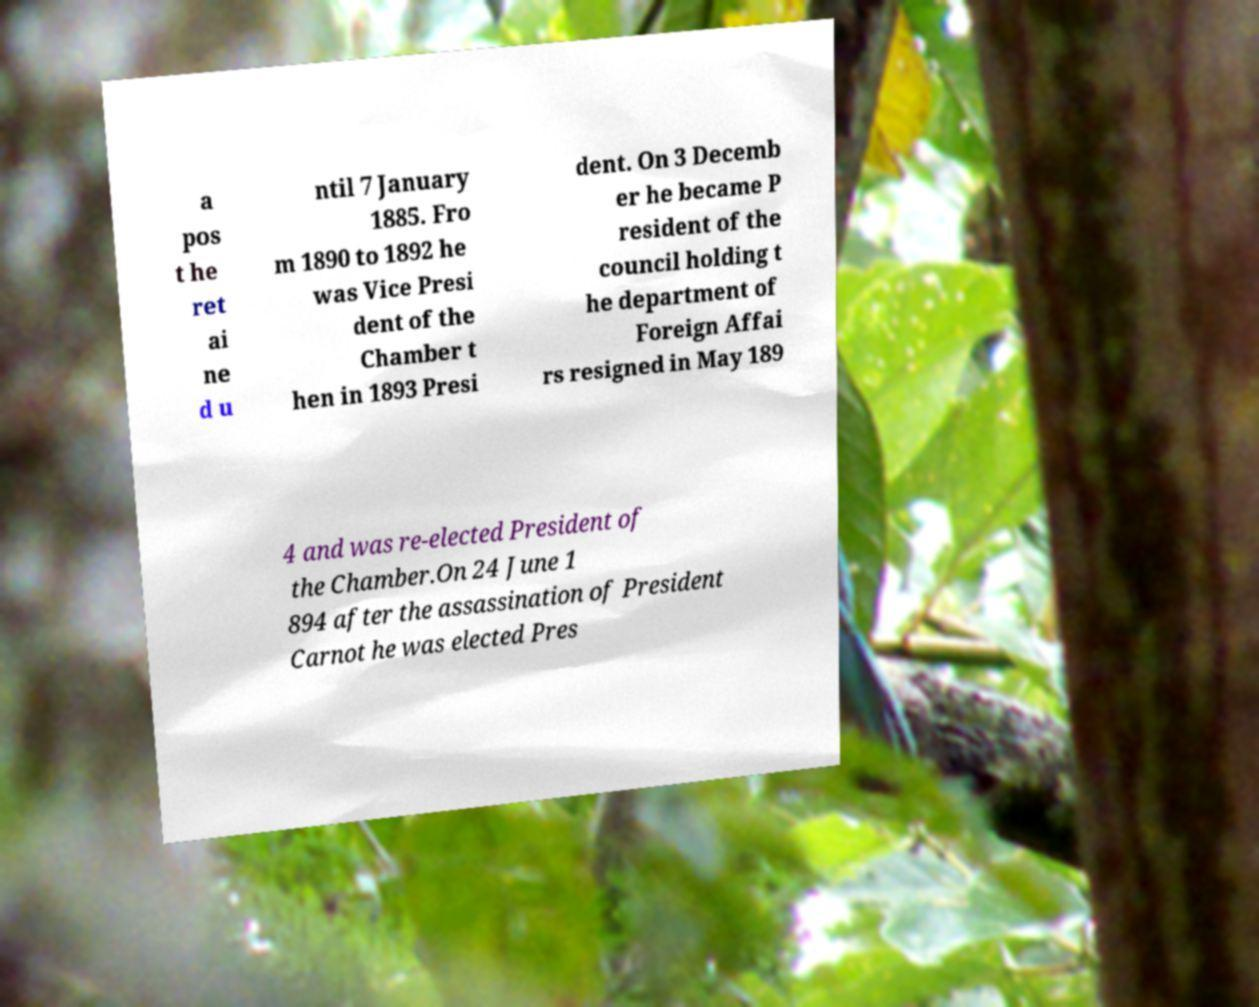Could you assist in decoding the text presented in this image and type it out clearly? a pos t he ret ai ne d u ntil 7 January 1885. Fro m 1890 to 1892 he was Vice Presi dent of the Chamber t hen in 1893 Presi dent. On 3 Decemb er he became P resident of the council holding t he department of Foreign Affai rs resigned in May 189 4 and was re-elected President of the Chamber.On 24 June 1 894 after the assassination of President Carnot he was elected Pres 